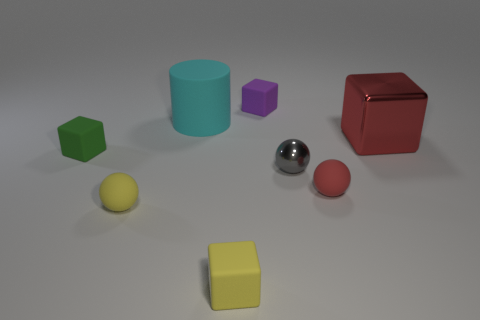Subtract all blue cubes. Subtract all green balls. How many cubes are left? 4 Add 1 rubber things. How many objects exist? 9 Subtract all cylinders. How many objects are left? 7 Add 5 tiny purple matte things. How many tiny purple matte things are left? 6 Add 1 big cyan metal spheres. How many big cyan metal spheres exist? 1 Subtract 1 purple blocks. How many objects are left? 7 Subtract all large gray metallic cubes. Subtract all small gray things. How many objects are left? 7 